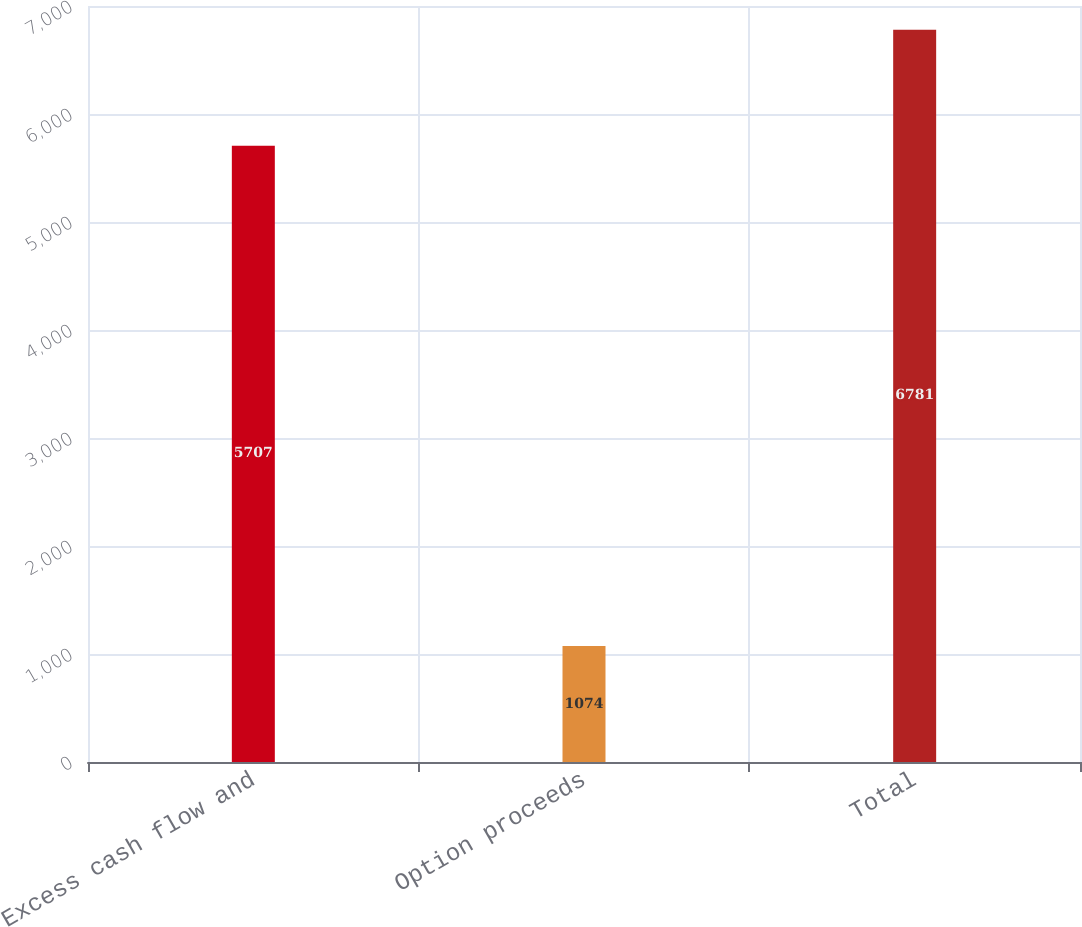Convert chart to OTSL. <chart><loc_0><loc_0><loc_500><loc_500><bar_chart><fcel>Excess cash flow and<fcel>Option proceeds<fcel>Total<nl><fcel>5707<fcel>1074<fcel>6781<nl></chart> 